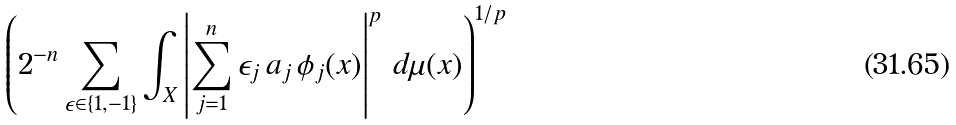<formula> <loc_0><loc_0><loc_500><loc_500>\left ( 2 ^ { - n } \sum _ { \epsilon \in \{ 1 , - 1 \} } \int _ { X } \left | \sum _ { j = 1 } ^ { n } \epsilon _ { j } \, a _ { j } \, \phi _ { j } ( x ) \right | ^ { p } \, d \mu ( x ) \right ) ^ { 1 / p }</formula> 